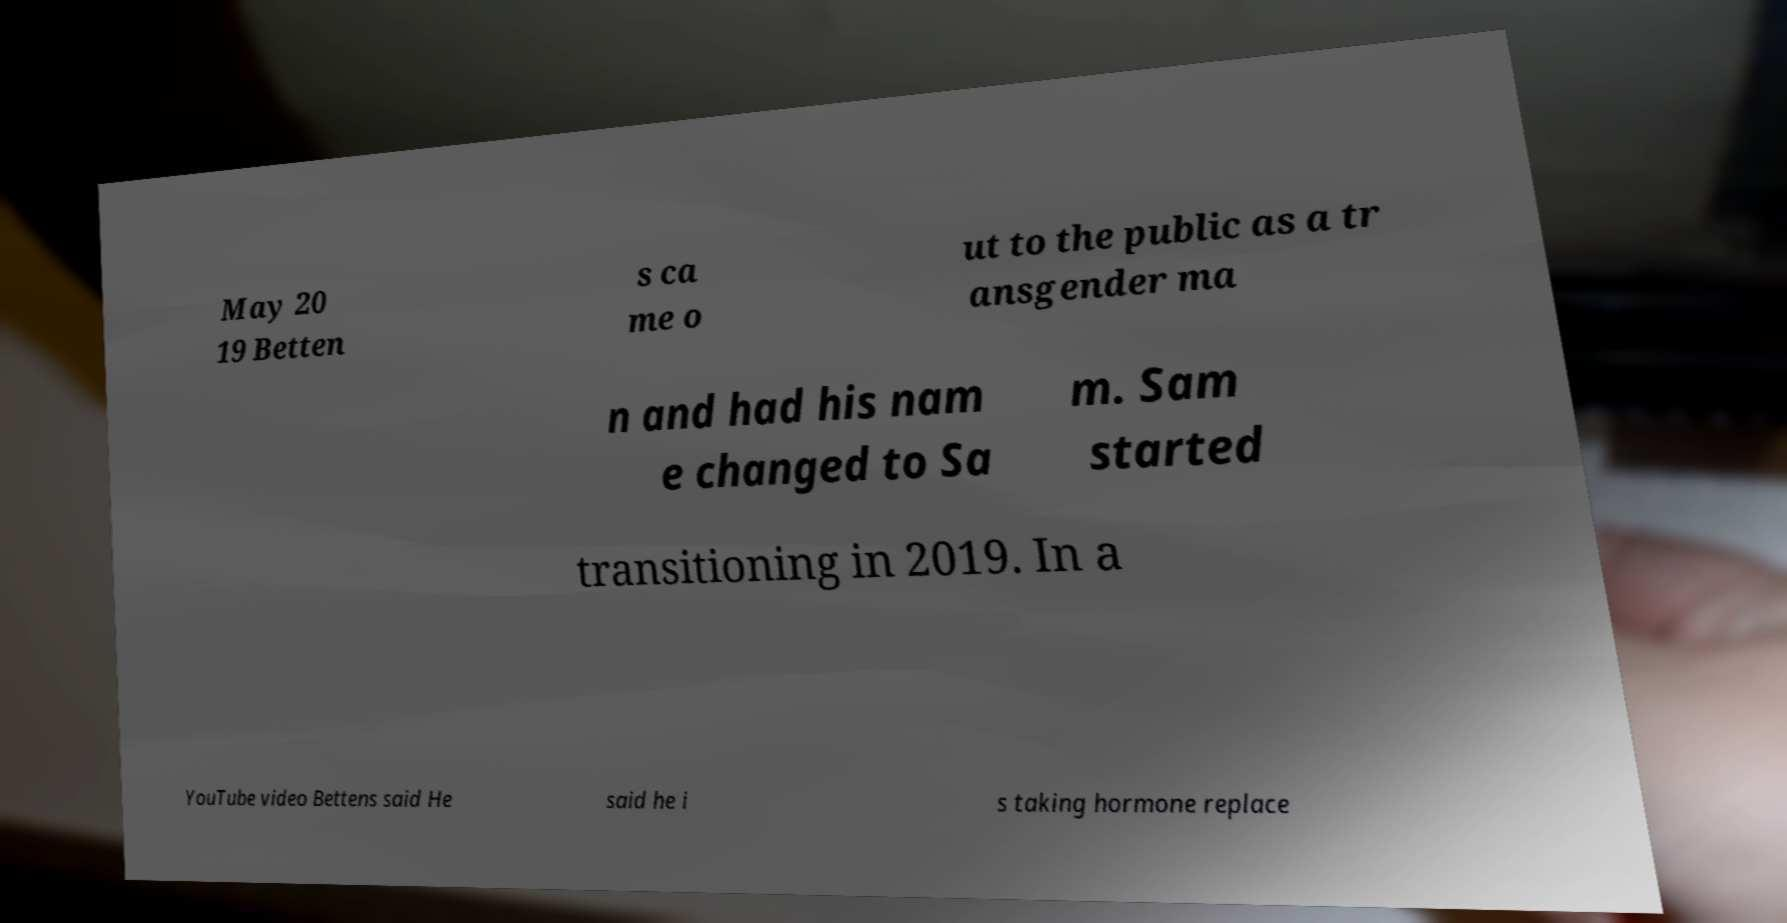I need the written content from this picture converted into text. Can you do that? May 20 19 Betten s ca me o ut to the public as a tr ansgender ma n and had his nam e changed to Sa m. Sam started transitioning in 2019. In a YouTube video Bettens said He said he i s taking hormone replace 